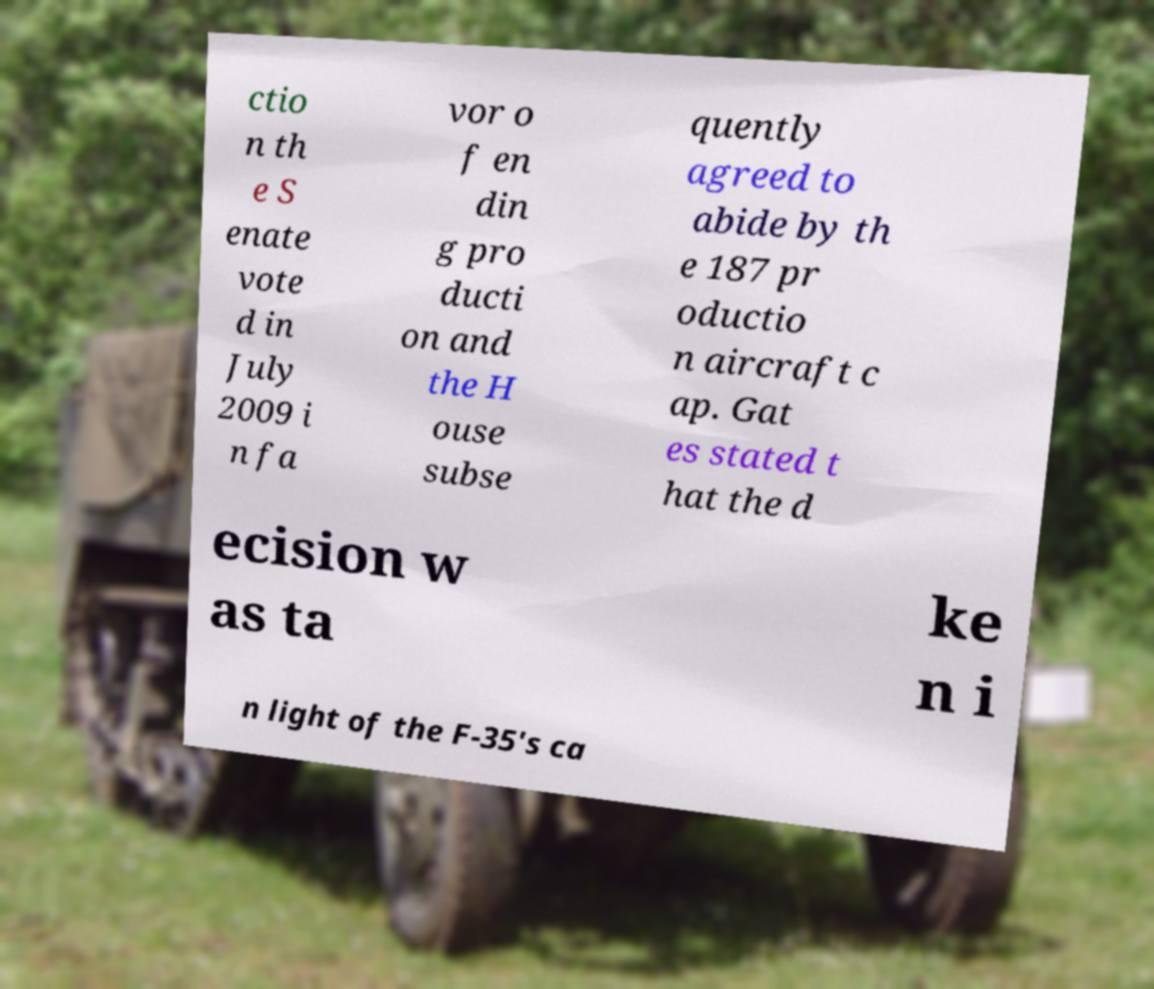Can you read and provide the text displayed in the image?This photo seems to have some interesting text. Can you extract and type it out for me? ctio n th e S enate vote d in July 2009 i n fa vor o f en din g pro ducti on and the H ouse subse quently agreed to abide by th e 187 pr oductio n aircraft c ap. Gat es stated t hat the d ecision w as ta ke n i n light of the F-35's ca 